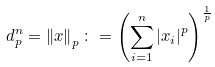Convert formula to latex. <formula><loc_0><loc_0><loc_500><loc_500>d ^ { n } _ { p } = \left \| x \right \| _ { p } \colon = \left ( \sum ^ { n } _ { i = 1 } \left | x _ { i } \right | ^ { p } \right ) ^ { \frac { 1 } { p } }</formula> 